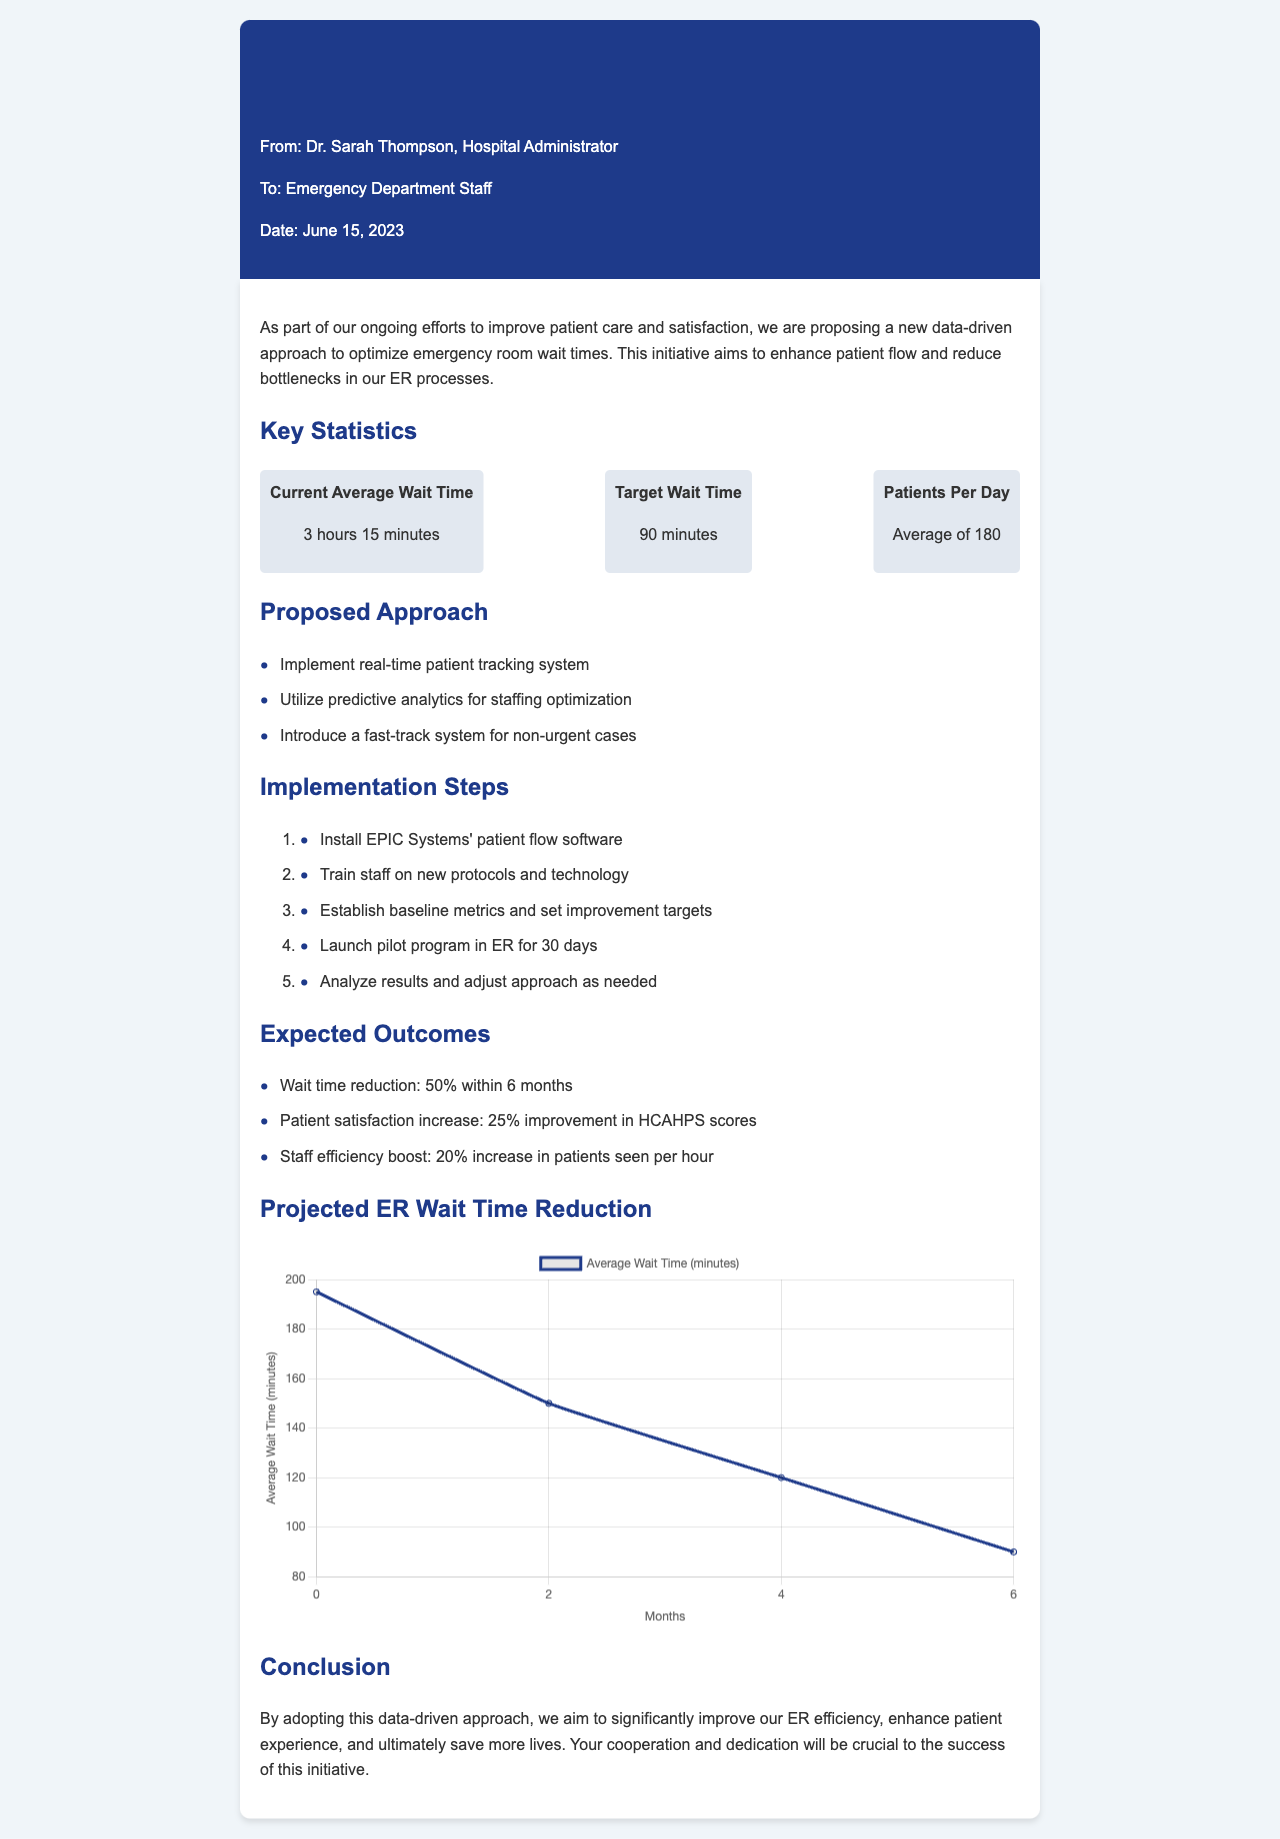What is the average current wait time? The average current wait time reported in the document is 3 hours 15 minutes.
Answer: 3 hours 15 minutes What is the target wait time? The target wait time outlined in the proposal is 90 minutes.
Answer: 90 minutes How many patients does the ER handle per day on average? The document states that the average number of patients per day is 180.
Answer: 180 What is the expected wait time reduction within six months? The proposal expects a wait time reduction of 50% within six months.
Answer: 50% What software is proposed to be installed? The document mentions installing EPIC Systems' patient flow software.
Answer: EPIC Systems' patient flow software What percentage increase in patient satisfaction is anticipated? The anticipated increase in patient satisfaction is 25% improvement in HCAHPS scores.
Answer: 25% What is the expected increase in staff efficiency? The document outlines an expected boost in staff efficiency of 20%.
Answer: 20% What is the primary goal of this proposal? The primary goal of the proposal is to optimize emergency room wait times.
Answer: Optimize emergency room wait times What type of system is proposed for non-urgent cases? A fast-track system is proposed for non-urgent cases.
Answer: fast-track system 